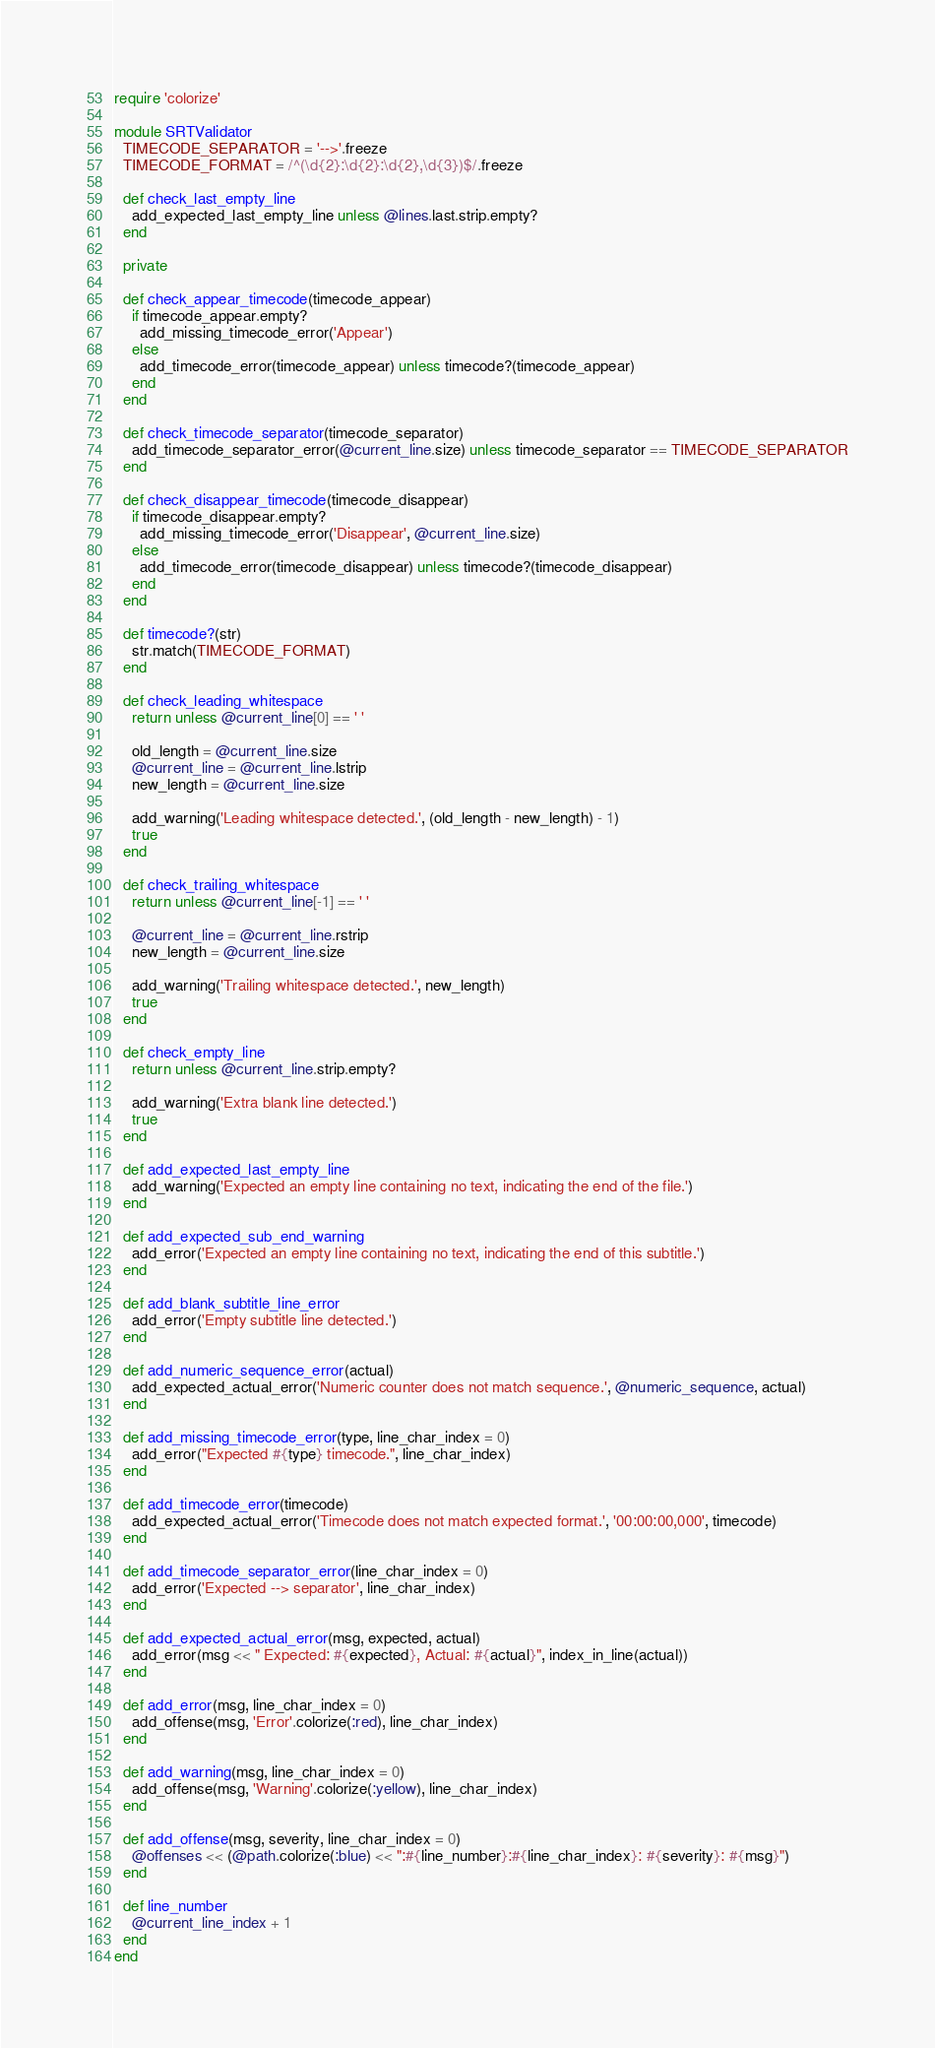Convert code to text. <code><loc_0><loc_0><loc_500><loc_500><_Ruby_>require 'colorize'

module SRTValidator
  TIMECODE_SEPARATOR = '-->'.freeze
  TIMECODE_FORMAT = /^(\d{2}:\d{2}:\d{2},\d{3})$/.freeze

  def check_last_empty_line
    add_expected_last_empty_line unless @lines.last.strip.empty?
  end

  private

  def check_appear_timecode(timecode_appear)
    if timecode_appear.empty?
      add_missing_timecode_error('Appear')
    else
      add_timecode_error(timecode_appear) unless timecode?(timecode_appear)
    end
  end

  def check_timecode_separator(timecode_separator)
    add_timecode_separator_error(@current_line.size) unless timecode_separator == TIMECODE_SEPARATOR
  end

  def check_disappear_timecode(timecode_disappear)
    if timecode_disappear.empty?
      add_missing_timecode_error('Disappear', @current_line.size)
    else
      add_timecode_error(timecode_disappear) unless timecode?(timecode_disappear)
    end
  end

  def timecode?(str)
    str.match(TIMECODE_FORMAT)
  end

  def check_leading_whitespace
    return unless @current_line[0] == ' '

    old_length = @current_line.size
    @current_line = @current_line.lstrip
    new_length = @current_line.size

    add_warning('Leading whitespace detected.', (old_length - new_length) - 1)
    true
  end

  def check_trailing_whitespace
    return unless @current_line[-1] == ' '

    @current_line = @current_line.rstrip
    new_length = @current_line.size

    add_warning('Trailing whitespace detected.', new_length)
    true
  end

  def check_empty_line
    return unless @current_line.strip.empty?

    add_warning('Extra blank line detected.')
    true
  end

  def add_expected_last_empty_line
    add_warning('Expected an empty line containing no text, indicating the end of the file.')
  end

  def add_expected_sub_end_warning
    add_error('Expected an empty line containing no text, indicating the end of this subtitle.')
  end

  def add_blank_subtitle_line_error
    add_error('Empty subtitle line detected.')
  end

  def add_numeric_sequence_error(actual)
    add_expected_actual_error('Numeric counter does not match sequence.', @numeric_sequence, actual)
  end

  def add_missing_timecode_error(type, line_char_index = 0)
    add_error("Expected #{type} timecode.", line_char_index)
  end

  def add_timecode_error(timecode)
    add_expected_actual_error('Timecode does not match expected format.', '00:00:00,000', timecode)
  end

  def add_timecode_separator_error(line_char_index = 0)
    add_error('Expected --> separator', line_char_index)
  end

  def add_expected_actual_error(msg, expected, actual)
    add_error(msg << " Expected: #{expected}, Actual: #{actual}", index_in_line(actual))
  end

  def add_error(msg, line_char_index = 0)
    add_offense(msg, 'Error'.colorize(:red), line_char_index)
  end

  def add_warning(msg, line_char_index = 0)
    add_offense(msg, 'Warning'.colorize(:yellow), line_char_index)
  end

  def add_offense(msg, severity, line_char_index = 0)
    @offenses << (@path.colorize(:blue) << ":#{line_number}:#{line_char_index}: #{severity}: #{msg}")
  end

  def line_number
    @current_line_index + 1
  end
end
</code> 